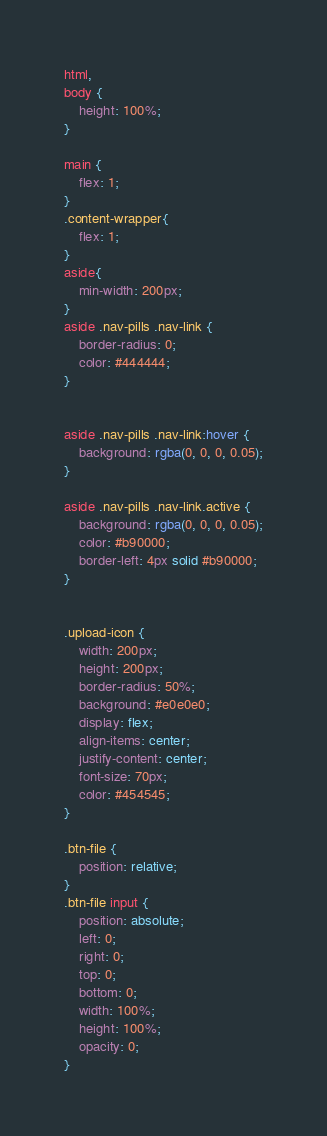Convert code to text. <code><loc_0><loc_0><loc_500><loc_500><_CSS_>html,
body {
    height: 100%;
}

main {
    flex: 1;
}
.content-wrapper{
    flex: 1;
}
aside{
    min-width: 200px;
}
aside .nav-pills .nav-link {
    border-radius: 0;
    color: #444444;
}


aside .nav-pills .nav-link:hover {
    background: rgba(0, 0, 0, 0.05);
}

aside .nav-pills .nav-link.active {
    background: rgba(0, 0, 0, 0.05);
    color: #b90000;
    border-left: 4px solid #b90000;
}


.upload-icon {
    width: 200px;
    height: 200px;
    border-radius: 50%;
    background: #e0e0e0;
    display: flex;
    align-items: center;
    justify-content: center;
    font-size: 70px;
    color: #454545;
}

.btn-file {
    position: relative;
}
.btn-file input {
    position: absolute;
    left: 0;
    right: 0;
    top: 0;
    bottom: 0;
    width: 100%;
    height: 100%;
    opacity: 0;
}</code> 